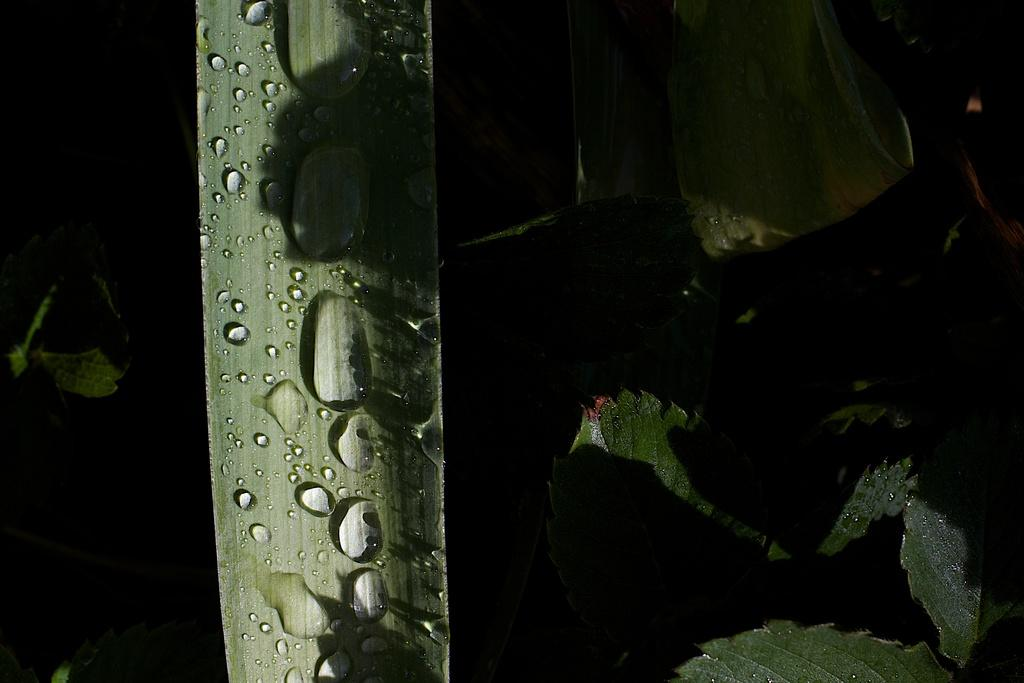What is the main subject of the image? The main subject of the image is a leaf with water drops. Are there any other leaves visible in the image? Yes, there are leaves on the right side of the image. What is the condition of the turkey in the image? There is no turkey present in the image. How many parcels are visible in the image? There are no parcels visible in the image. 